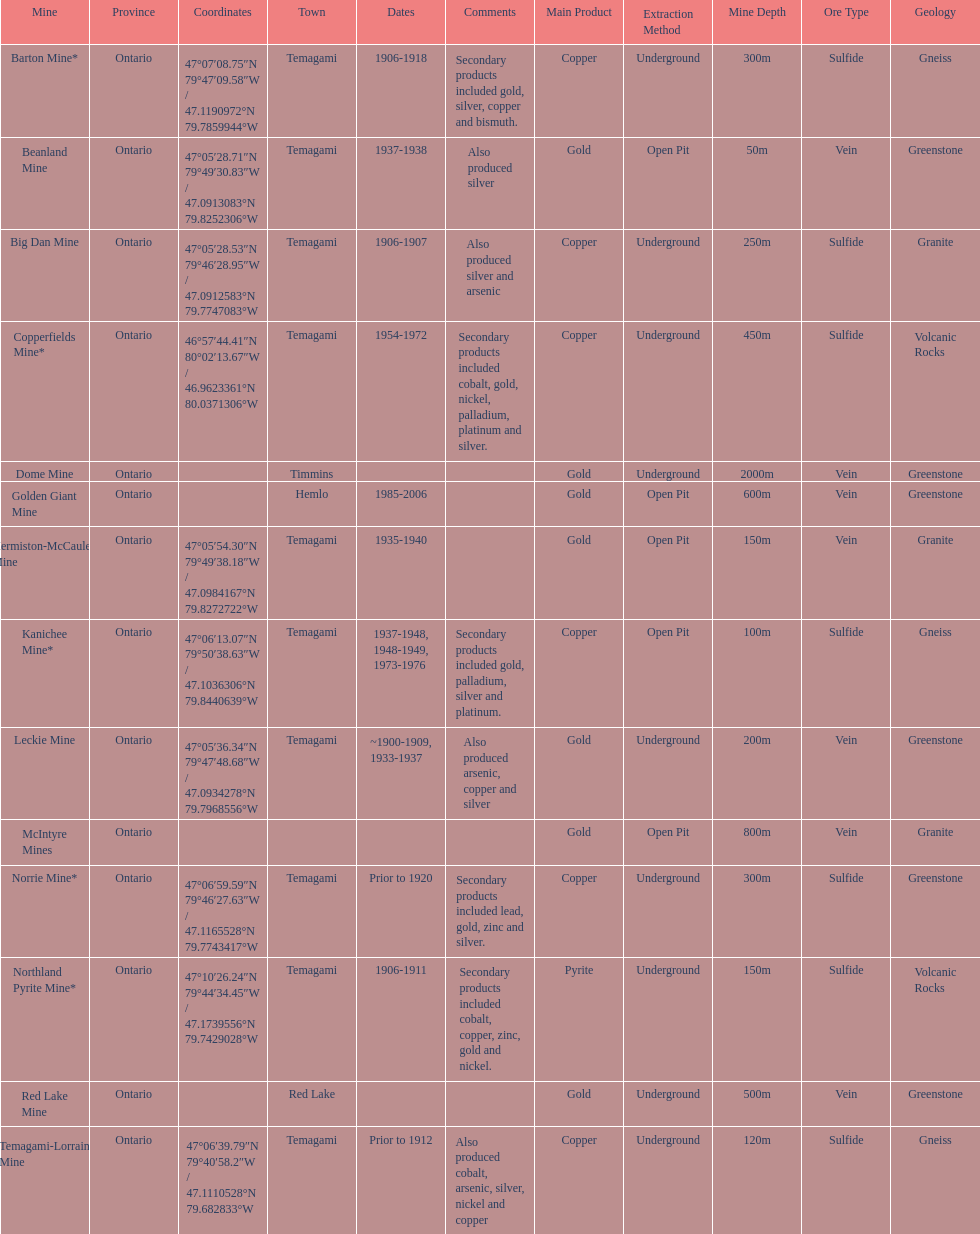Which mine was open longer, golden giant or beanland mine? Golden Giant Mine. 